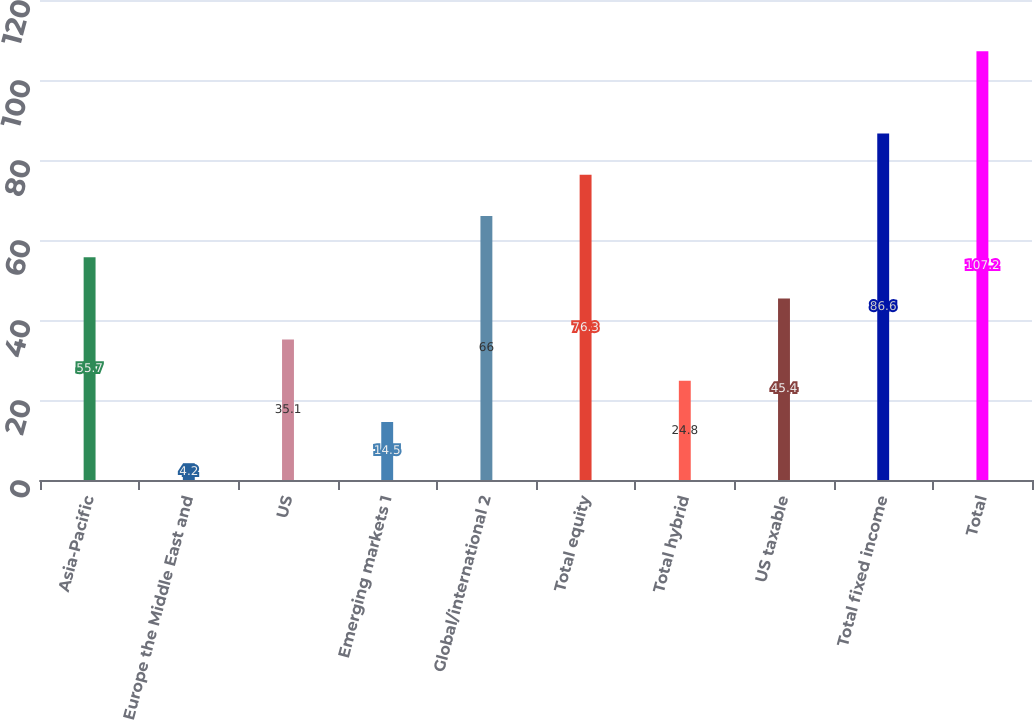Convert chart. <chart><loc_0><loc_0><loc_500><loc_500><bar_chart><fcel>Asia-Pacific<fcel>Europe the Middle East and<fcel>US<fcel>Emerging markets 1<fcel>Global/international 2<fcel>Total equity<fcel>Total hybrid<fcel>US taxable<fcel>Total fixed income<fcel>Total<nl><fcel>55.7<fcel>4.2<fcel>35.1<fcel>14.5<fcel>66<fcel>76.3<fcel>24.8<fcel>45.4<fcel>86.6<fcel>107.2<nl></chart> 